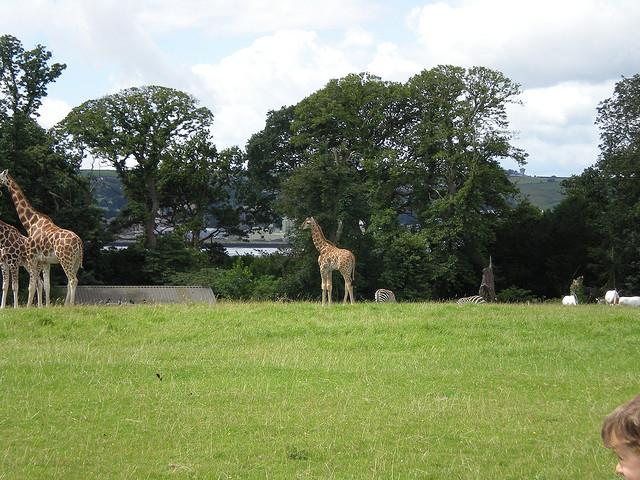How many species of animals do you see?
Answer briefly. 2. What kind of animals are these?
Answer briefly. Giraffes. Is there a child?
Be succinct. Yes. Are these animals laying down?
Keep it brief. No. Are there any branches on the ground?
Write a very short answer. No. Is it daytime?
Keep it brief. Yes. How many horses are there?
Short answer required. 0. 